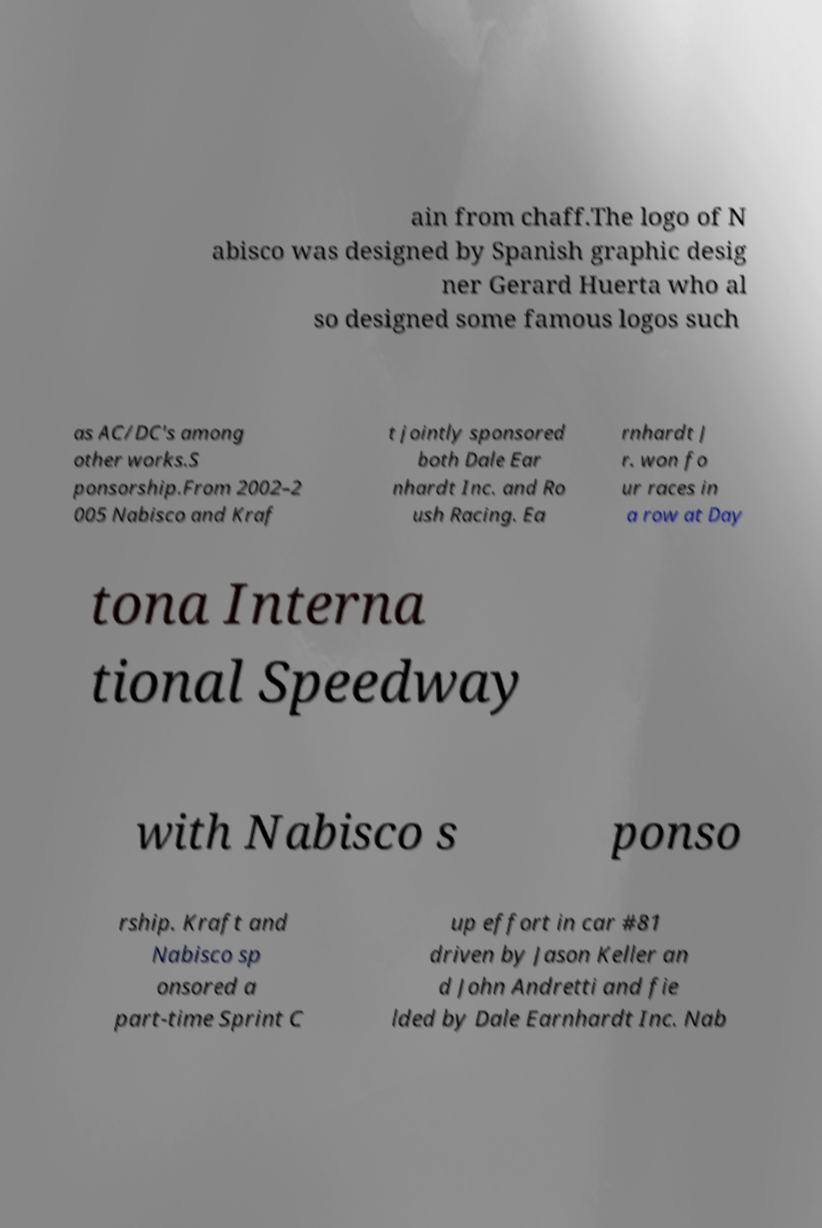Could you extract and type out the text from this image? ain from chaff.The logo of N abisco was designed by Spanish graphic desig ner Gerard Huerta who al so designed some famous logos such as AC/DC's among other works.S ponsorship.From 2002–2 005 Nabisco and Kraf t jointly sponsored both Dale Ear nhardt Inc. and Ro ush Racing. Ea rnhardt J r. won fo ur races in a row at Day tona Interna tional Speedway with Nabisco s ponso rship. Kraft and Nabisco sp onsored a part-time Sprint C up effort in car #81 driven by Jason Keller an d John Andretti and fie lded by Dale Earnhardt Inc. Nab 